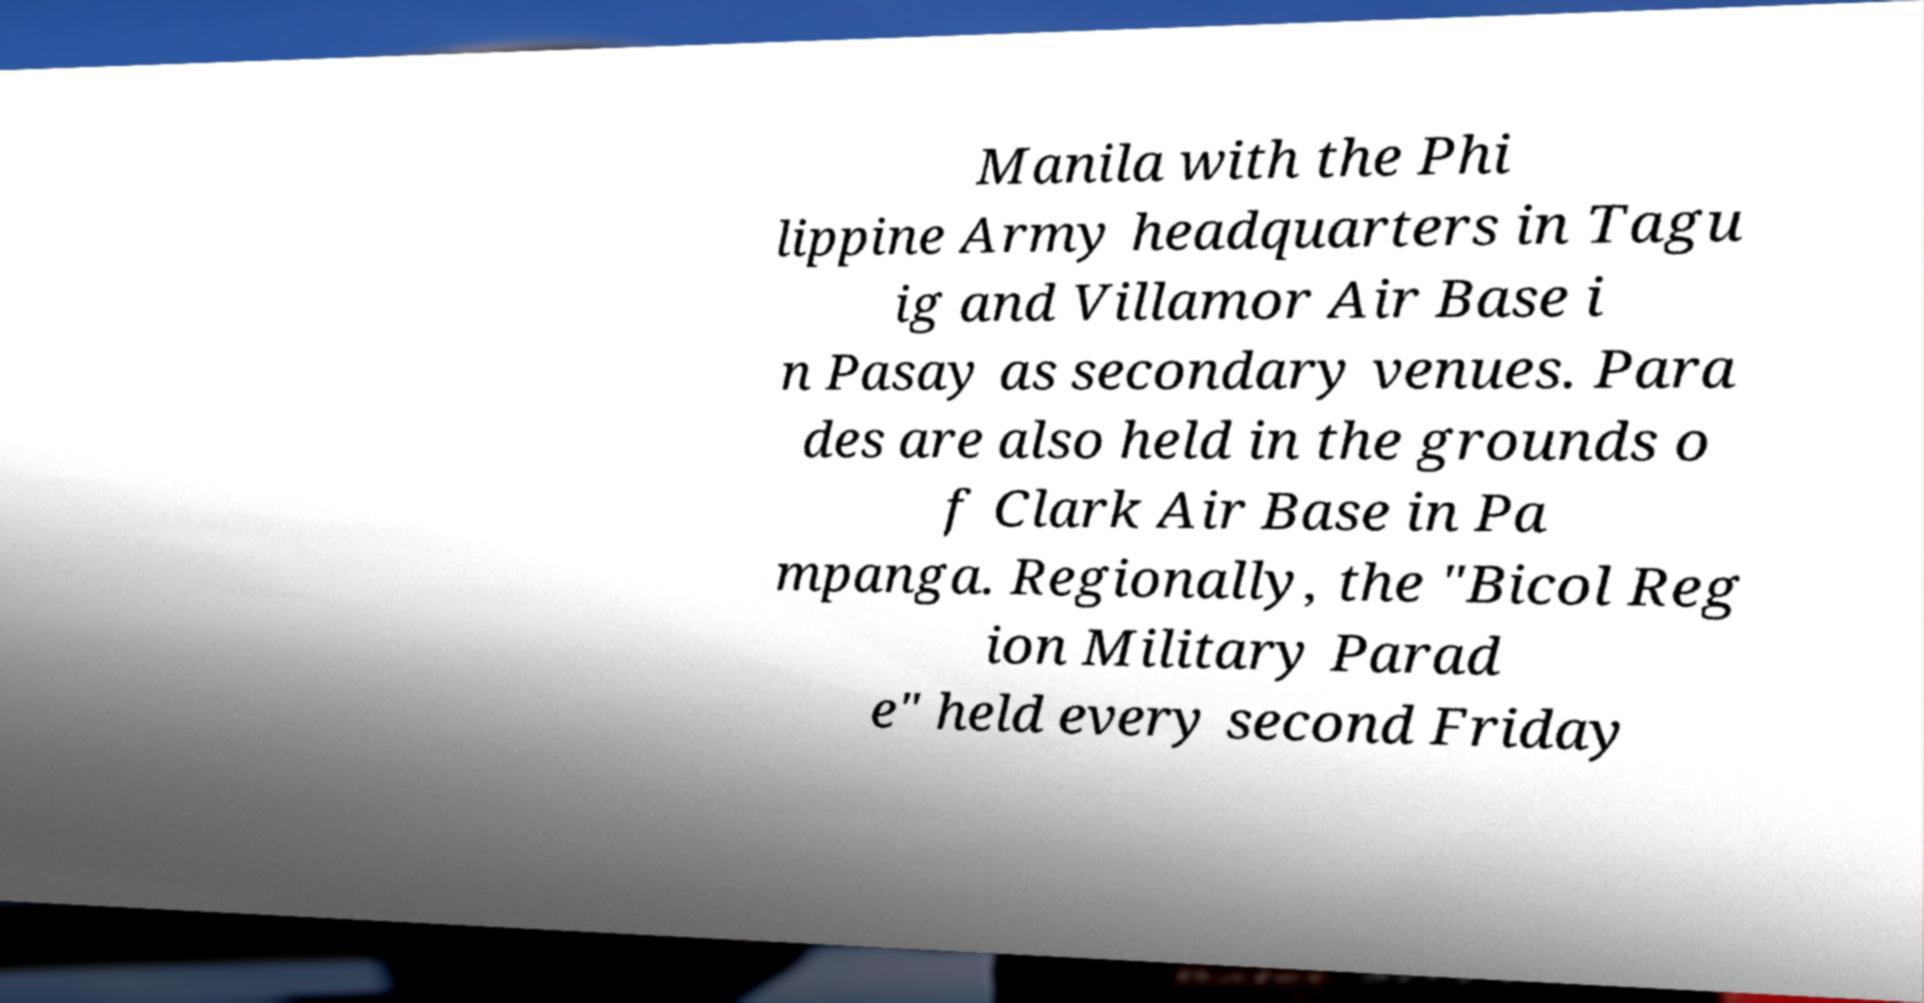I need the written content from this picture converted into text. Can you do that? Manila with the Phi lippine Army headquarters in Tagu ig and Villamor Air Base i n Pasay as secondary venues. Para des are also held in the grounds o f Clark Air Base in Pa mpanga. Regionally, the "Bicol Reg ion Military Parad e" held every second Friday 